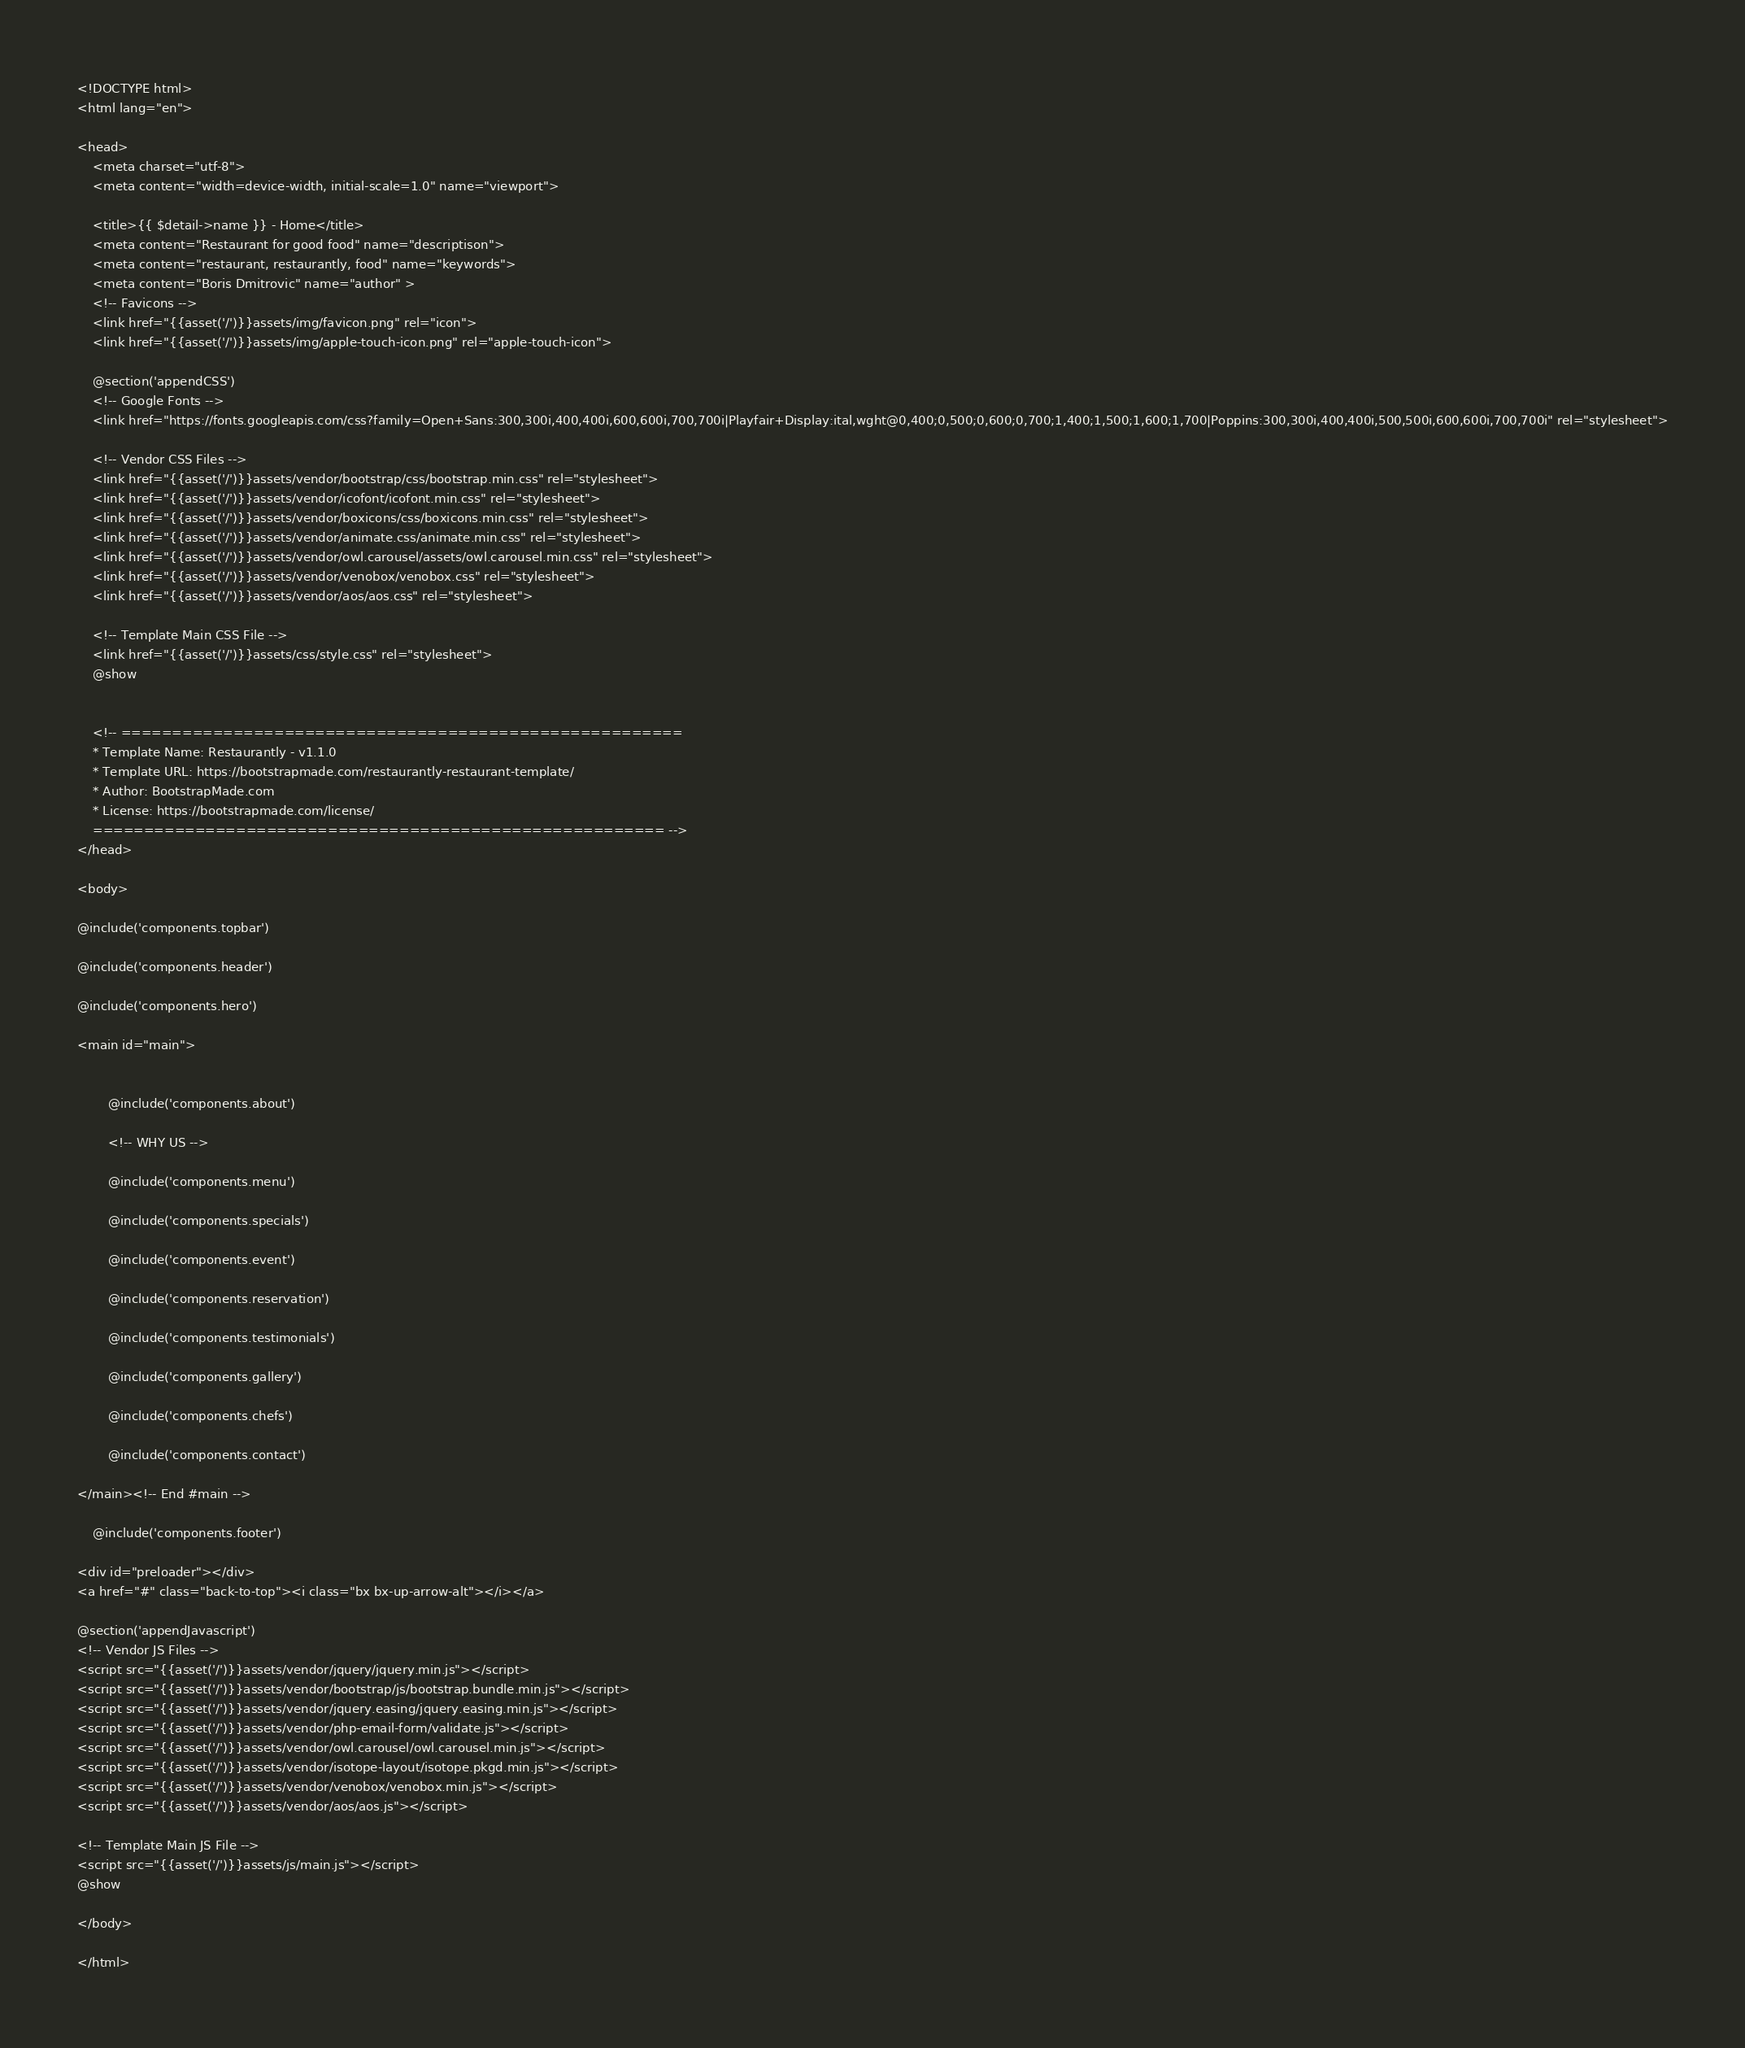<code> <loc_0><loc_0><loc_500><loc_500><_PHP_><!DOCTYPE html>
<html lang="en">

<head>
    <meta charset="utf-8">
    <meta content="width=device-width, initial-scale=1.0" name="viewport">

    <title>{{ $detail->name }} - Home</title>
    <meta content="Restaurant for good food" name="descriptison">
    <meta content="restaurant, restaurantly, food" name="keywords">
    <meta content="Boris Dmitrovic" name="author" >
    <!-- Favicons -->
    <link href="{{asset('/')}}assets/img/favicon.png" rel="icon">
    <link href="{{asset('/')}}assets/img/apple-touch-icon.png" rel="apple-touch-icon">

    @section('appendCSS')
    <!-- Google Fonts -->
    <link href="https://fonts.googleapis.com/css?family=Open+Sans:300,300i,400,400i,600,600i,700,700i|Playfair+Display:ital,wght@0,400;0,500;0,600;0,700;1,400;1,500;1,600;1,700|Poppins:300,300i,400,400i,500,500i,600,600i,700,700i" rel="stylesheet">

    <!-- Vendor CSS Files -->
    <link href="{{asset('/')}}assets/vendor/bootstrap/css/bootstrap.min.css" rel="stylesheet">
    <link href="{{asset('/')}}assets/vendor/icofont/icofont.min.css" rel="stylesheet">
    <link href="{{asset('/')}}assets/vendor/boxicons/css/boxicons.min.css" rel="stylesheet">
    <link href="{{asset('/')}}assets/vendor/animate.css/animate.min.css" rel="stylesheet">
    <link href="{{asset('/')}}assets/vendor/owl.carousel/assets/owl.carousel.min.css" rel="stylesheet">
    <link href="{{asset('/')}}assets/vendor/venobox/venobox.css" rel="stylesheet">
    <link href="{{asset('/')}}assets/vendor/aos/aos.css" rel="stylesheet">

    <!-- Template Main CSS File -->
    <link href="{{asset('/')}}assets/css/style.css" rel="stylesheet">
    @show


    <!-- =======================================================
    * Template Name: Restaurantly - v1.1.0
    * Template URL: https://bootstrapmade.com/restaurantly-restaurant-template/
    * Author: BootstrapMade.com
    * License: https://bootstrapmade.com/license/
    ======================================================== -->
</head>

<body>

@include('components.topbar')

@include('components.header')

@include('components.hero')

<main id="main">


        @include('components.about')

        <!-- WHY US -->

        @include('components.menu')

        @include('components.specials')

        @include('components.event')

        @include('components.reservation')

        @include('components.testimonials')

        @include('components.gallery')

        @include('components.chefs')

        @include('components.contact')

</main><!-- End #main -->

    @include('components.footer')

<div id="preloader"></div>
<a href="#" class="back-to-top"><i class="bx bx-up-arrow-alt"></i></a>

@section('appendJavascript')
<!-- Vendor JS Files -->
<script src="{{asset('/')}}assets/vendor/jquery/jquery.min.js"></script>
<script src="{{asset('/')}}assets/vendor/bootstrap/js/bootstrap.bundle.min.js"></script>
<script src="{{asset('/')}}assets/vendor/jquery.easing/jquery.easing.min.js"></script>
<script src="{{asset('/')}}assets/vendor/php-email-form/validate.js"></script>
<script src="{{asset('/')}}assets/vendor/owl.carousel/owl.carousel.min.js"></script>
<script src="{{asset('/')}}assets/vendor/isotope-layout/isotope.pkgd.min.js"></script>
<script src="{{asset('/')}}assets/vendor/venobox/venobox.min.js"></script>
<script src="{{asset('/')}}assets/vendor/aos/aos.js"></script>

<!-- Template Main JS File -->
<script src="{{asset('/')}}assets/js/main.js"></script>
@show

</body>

</html>
</code> 